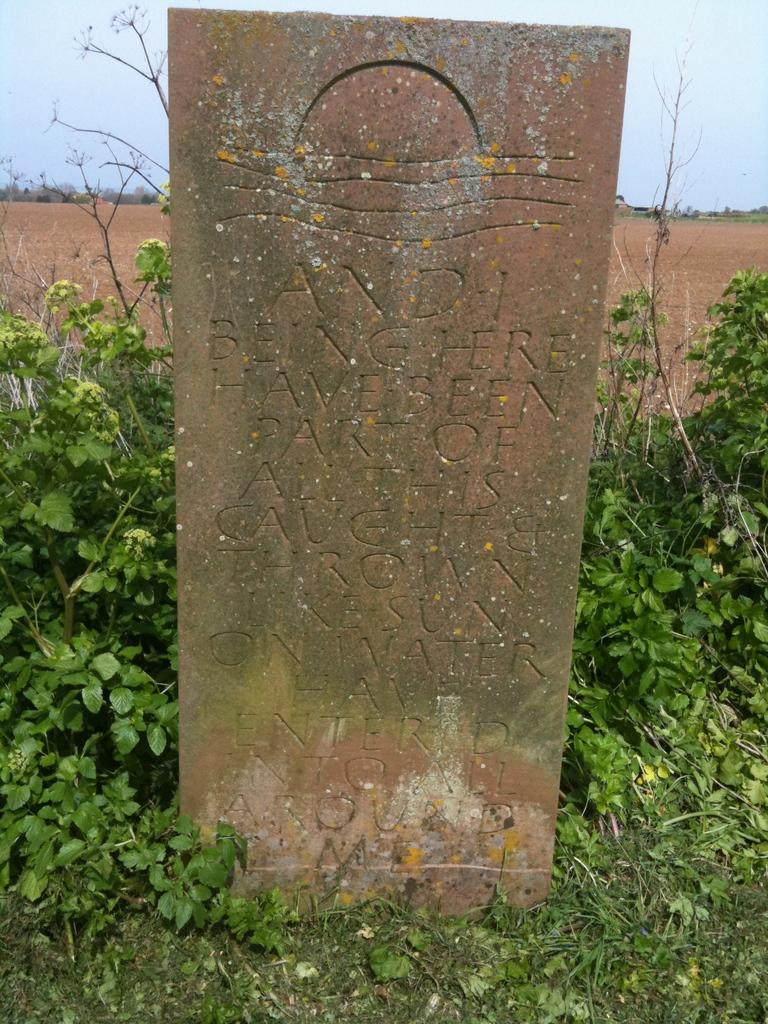What is the main object in the image with text on it? There is a stone with text in the image. What type of vegetation is present on the ground in the image? There are plants on the ground in the image. What can be seen in the background of the image? The sky is visible in the background of the image. How many crows are sitting on the stone in the image? There are no crows present in the image; it only features a stone with text and plants on the ground. 